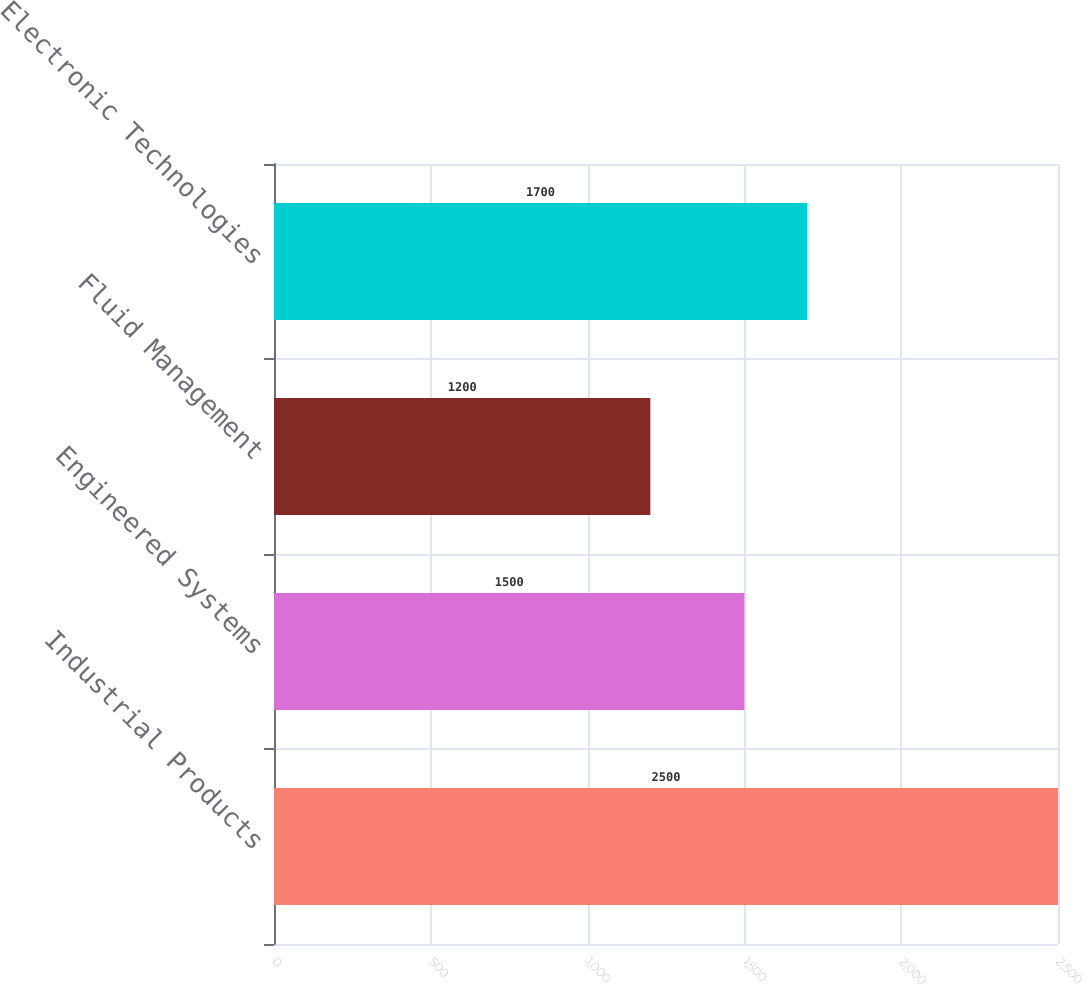Convert chart. <chart><loc_0><loc_0><loc_500><loc_500><bar_chart><fcel>Industrial Products<fcel>Engineered Systems<fcel>Fluid Management<fcel>Electronic Technologies<nl><fcel>2500<fcel>1500<fcel>1200<fcel>1700<nl></chart> 